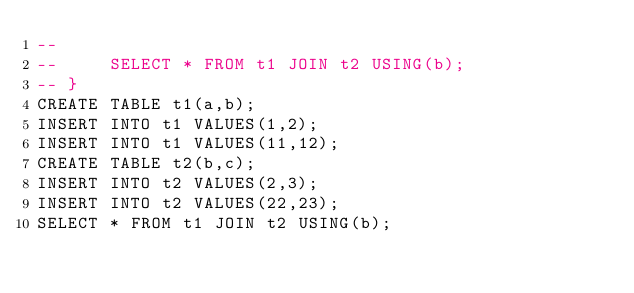Convert code to text. <code><loc_0><loc_0><loc_500><loc_500><_SQL_>-- 
--     SELECT * FROM t1 JOIN t2 USING(b);
-- }
CREATE TABLE t1(a,b);
INSERT INTO t1 VALUES(1,2);
INSERT INTO t1 VALUES(11,12);
CREATE TABLE t2(b,c);
INSERT INTO t2 VALUES(2,3);
INSERT INTO t2 VALUES(22,23);
SELECT * FROM t1 JOIN t2 USING(b);</code> 